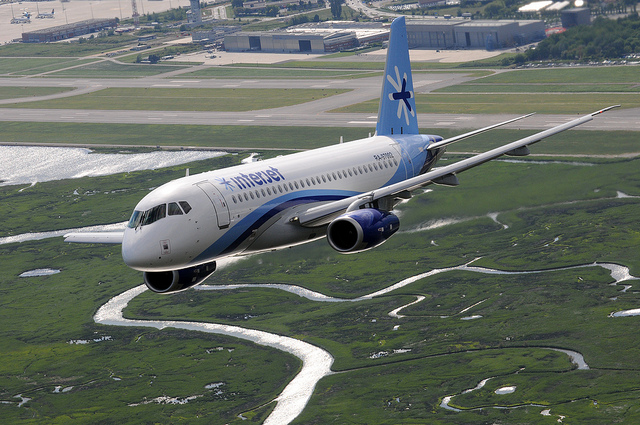Identify and read out the text in this image. interjet 